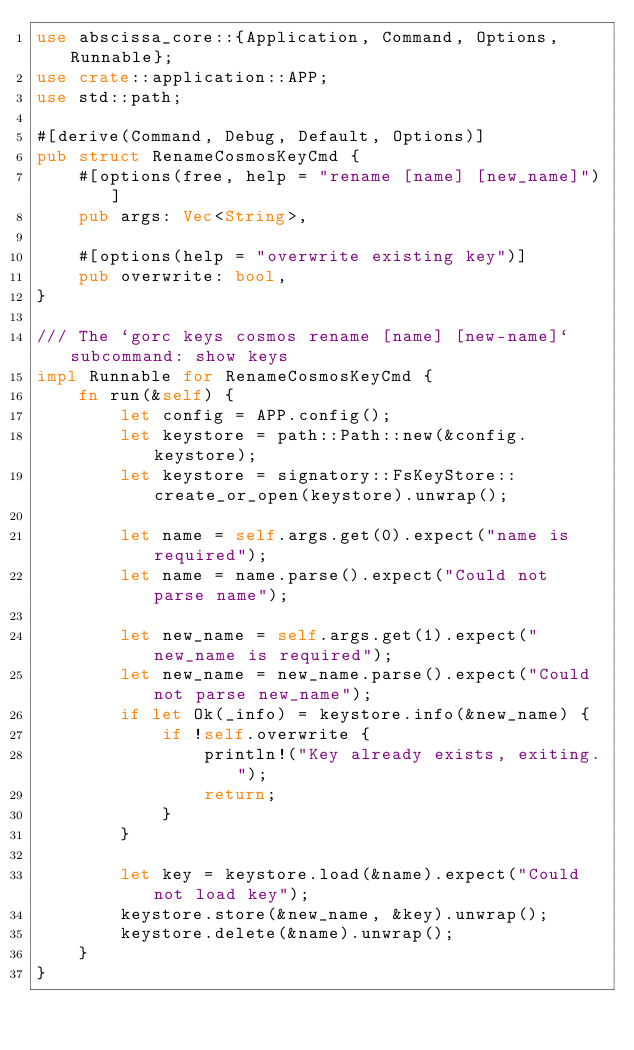Convert code to text. <code><loc_0><loc_0><loc_500><loc_500><_Rust_>use abscissa_core::{Application, Command, Options, Runnable};
use crate::application::APP;
use std::path;

#[derive(Command, Debug, Default, Options)]
pub struct RenameCosmosKeyCmd {
    #[options(free, help = "rename [name] [new_name]")]
    pub args: Vec<String>,

    #[options(help = "overwrite existing key")]
    pub overwrite: bool,
}

/// The `gorc keys cosmos rename [name] [new-name]` subcommand: show keys
impl Runnable for RenameCosmosKeyCmd {
    fn run(&self) {
        let config = APP.config();
        let keystore = path::Path::new(&config.keystore);
        let keystore = signatory::FsKeyStore::create_or_open(keystore).unwrap();

        let name = self.args.get(0).expect("name is required");
        let name = name.parse().expect("Could not parse name");

        let new_name = self.args.get(1).expect("new_name is required");
        let new_name = new_name.parse().expect("Could not parse new_name");
        if let Ok(_info) = keystore.info(&new_name) {
            if !self.overwrite {
                println!("Key already exists, exiting.");
                return;
            }
        }

        let key = keystore.load(&name).expect("Could not load key");
        keystore.store(&new_name, &key).unwrap();
        keystore.delete(&name).unwrap();
    }
}
</code> 